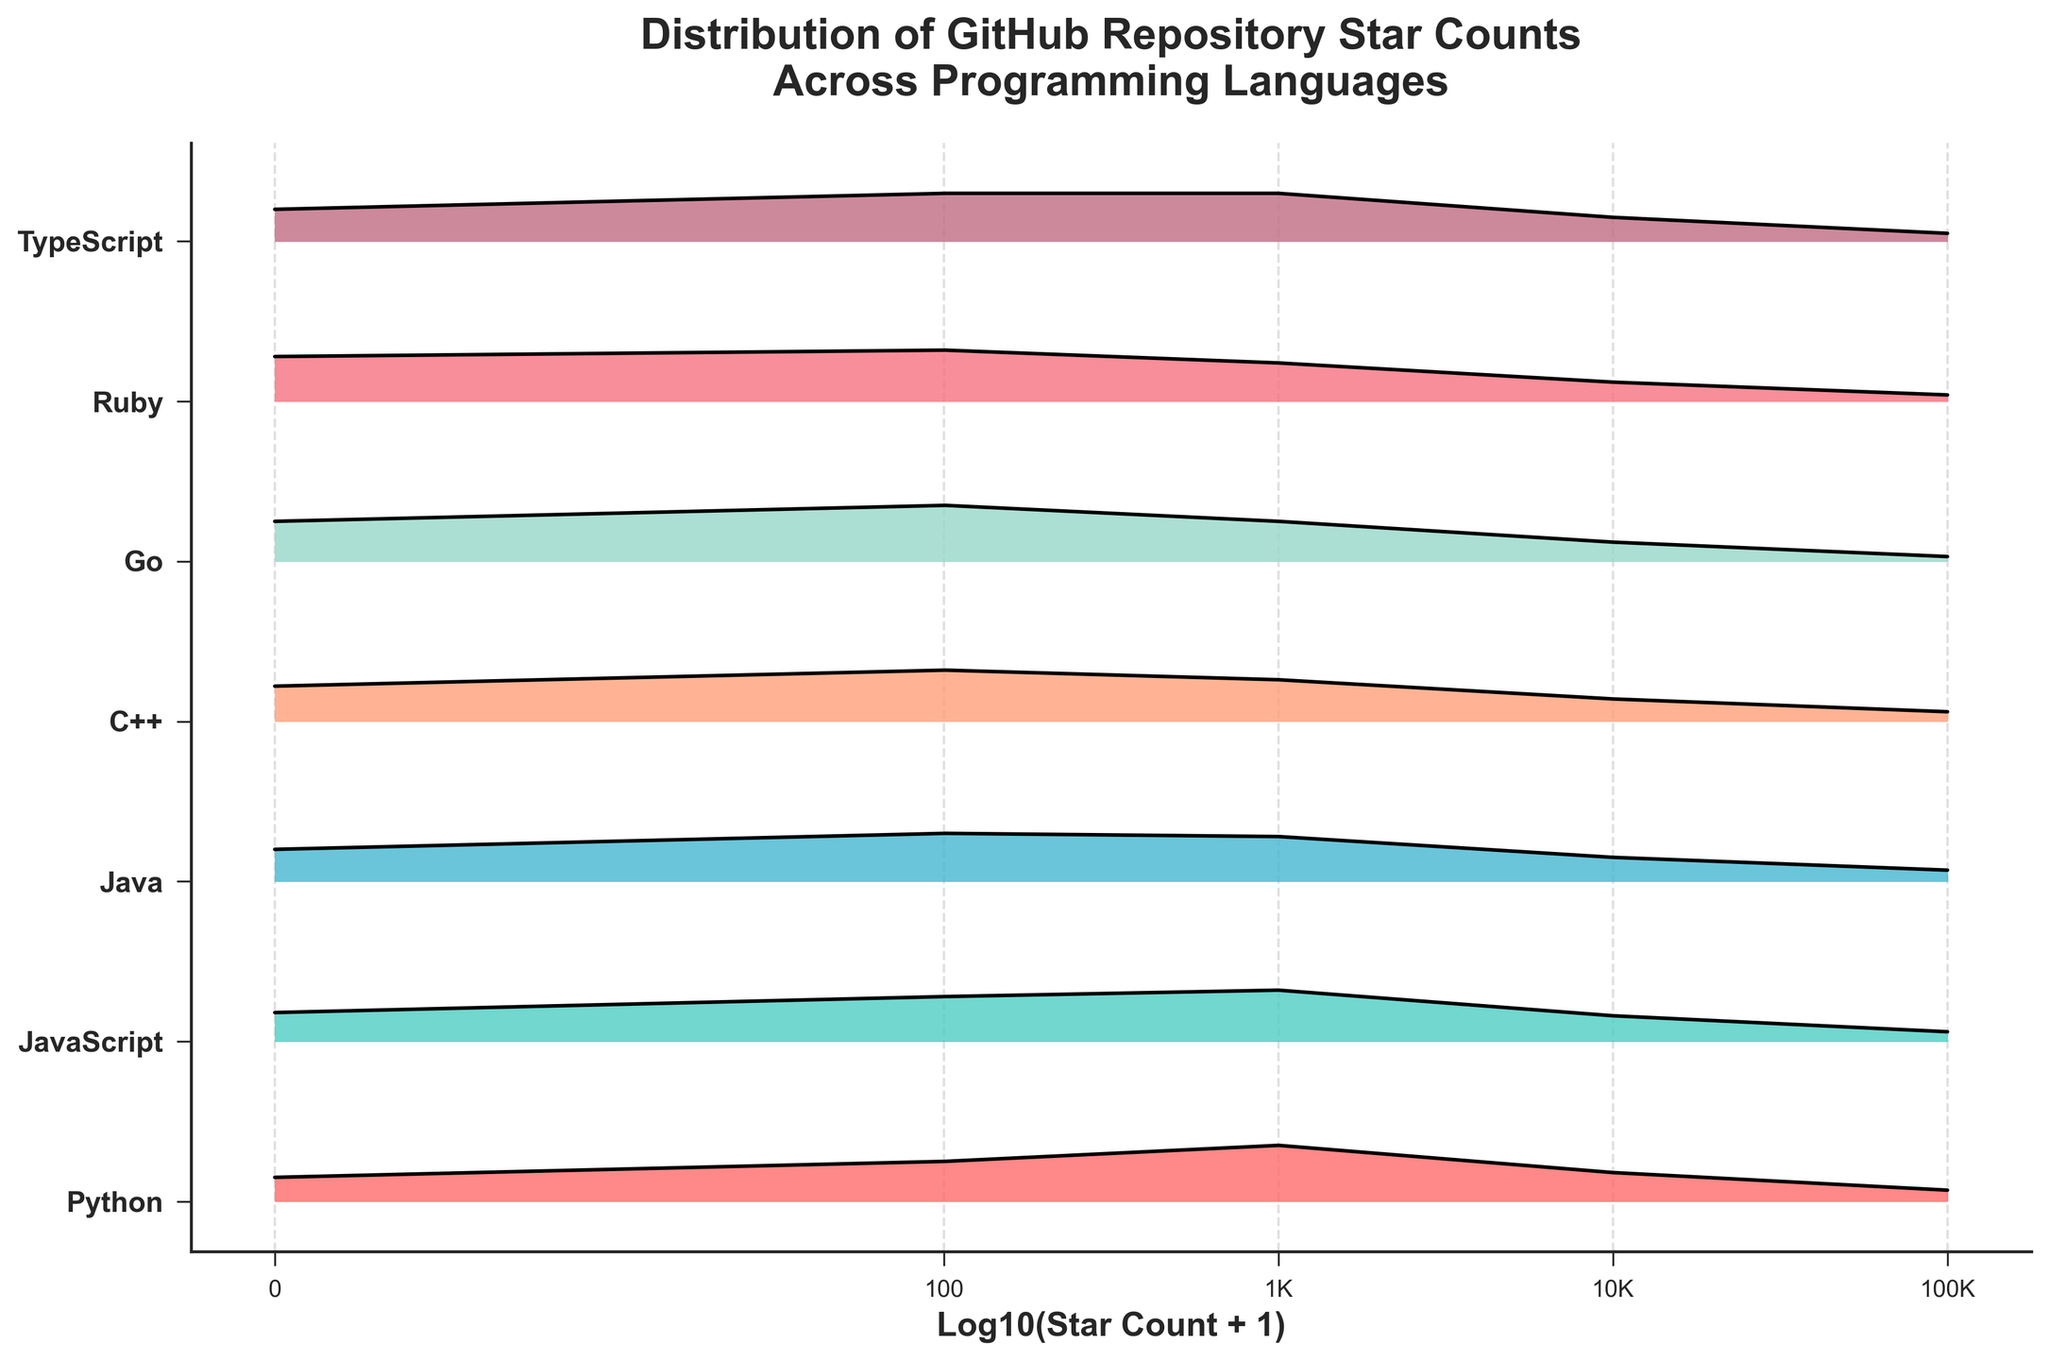What's the title of the figure? The title of the figure is a text displayed at the top of the plot. It provides an overview of what the figure represents.
Answer: Distribution of GitHub Repository Star Counts Across Programming Languages Which programming language has the highest initial density for star counts? To find the highest initial density, look at the density value for star counts of 0 for each language, which is displayed on the leftmost side of the plot. Compare these values.
Answer: Ruby How does Python's star count distribution compare to Go's? Python and Go can be compared by examining the distribution of densities across different star counts for both languages. Python starts with lower initial density (~0.15) compared to Go (~0.25) but has higher densities at higher star counts, especially around 1,000 stars.
Answer: Python has lower initial density but higher mid star count density Which programming language has the steepest drop in density after 100 stars? To determine the steepest drop, examine the changes in density from the 100-star mark to the next higher star count for each language. The language with the largest difference in densities represents the steepest drop. Go shows a density drop from ~0.35 to ~0.25, i.e., a 0.10 drop, which is significant.
Answer: Go At what star count does JavaScript's density start to decrease significantly? Identify the star count where JavaScript's density shows a noticeable decrease from higher density values. Look for a drop in the curve from one star count to the next.
Answer: 1,000 stars What are the y-axis labels representing? The y-axis labels list the different programming languages included in the plot. Each label corresponds to the density distribution of star counts for that language.
Answer: Programming languages Compare the density of C++ and JavaScript for 1,000 stars. Locate the densities for C++ and JavaScript at 1,000 stars. C++ has a density of ~0.26, while JavaScript has a slightly higher density of ~0.32.
Answer: JavaScript has a higher density Which programming language has the smallest density gap between 100 and 1,000 stars? Examine the density values for 100 and 1,000 stars for each language, then calculate the difference and compare them. C++ has densities of ~0.32 and ~0.26, resulting in a gap of 0.06 which is smaller compared to other languages.
Answer: C++ What is the x-axis labeled as? The x-axis label provides context for what the x-axis values represent, in this case, related to the star counts on GitHub.
Answer: Log10(Star Count + 1) How many different programming languages are illustrated in the plot? Count the unique programming languages listed on the y-axis labels. There are Python, JavaScript, Java, C++, Go, Ruby, and TypeScript.
Answer: 7 